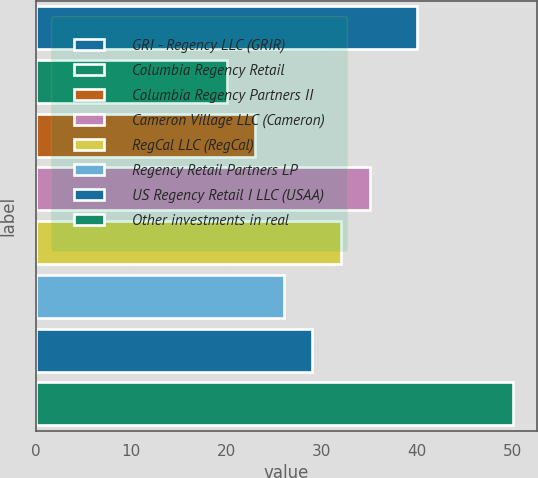<chart> <loc_0><loc_0><loc_500><loc_500><bar_chart><fcel>GRI - Regency LLC (GRIR)<fcel>Columbia Regency Retail<fcel>Columbia Regency Partners II<fcel>Cameron Village LLC (Cameron)<fcel>RegCal LLC (RegCal)<fcel>Regency Retail Partners LP<fcel>US Regency Retail I LLC (USAA)<fcel>Other investments in real<nl><fcel>40<fcel>20<fcel>23<fcel>35<fcel>32<fcel>26<fcel>29<fcel>50<nl></chart> 